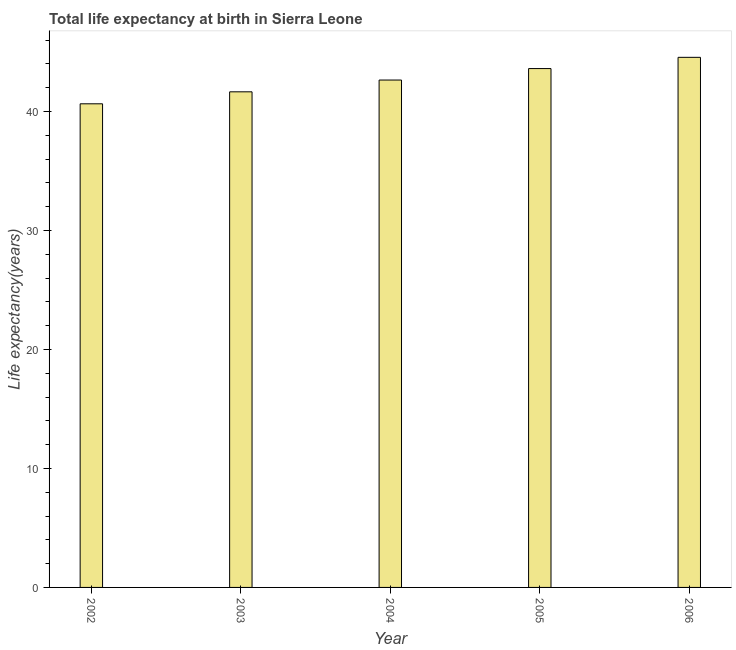Does the graph contain grids?
Ensure brevity in your answer.  No. What is the title of the graph?
Keep it short and to the point. Total life expectancy at birth in Sierra Leone. What is the label or title of the X-axis?
Make the answer very short. Year. What is the label or title of the Y-axis?
Keep it short and to the point. Life expectancy(years). What is the life expectancy at birth in 2006?
Your answer should be compact. 44.55. Across all years, what is the maximum life expectancy at birth?
Provide a succinct answer. 44.55. Across all years, what is the minimum life expectancy at birth?
Keep it short and to the point. 40.64. In which year was the life expectancy at birth minimum?
Your response must be concise. 2002. What is the sum of the life expectancy at birth?
Provide a short and direct response. 213.08. What is the difference between the life expectancy at birth in 2002 and 2005?
Your response must be concise. -2.96. What is the average life expectancy at birth per year?
Offer a very short reply. 42.62. What is the median life expectancy at birth?
Your response must be concise. 42.64. In how many years, is the life expectancy at birth greater than 24 years?
Your response must be concise. 5. What is the ratio of the life expectancy at birth in 2002 to that in 2004?
Offer a terse response. 0.95. What is the difference between the highest and the second highest life expectancy at birth?
Provide a succinct answer. 0.94. What is the difference between the highest and the lowest life expectancy at birth?
Offer a very short reply. 3.91. How many years are there in the graph?
Keep it short and to the point. 5. What is the Life expectancy(years) of 2002?
Make the answer very short. 40.64. What is the Life expectancy(years) in 2003?
Provide a short and direct response. 41.65. What is the Life expectancy(years) in 2004?
Offer a terse response. 42.64. What is the Life expectancy(years) of 2005?
Offer a very short reply. 43.6. What is the Life expectancy(years) of 2006?
Ensure brevity in your answer.  44.55. What is the difference between the Life expectancy(years) in 2002 and 2003?
Provide a short and direct response. -1.01. What is the difference between the Life expectancy(years) in 2002 and 2004?
Your answer should be compact. -2. What is the difference between the Life expectancy(years) in 2002 and 2005?
Your answer should be very brief. -2.96. What is the difference between the Life expectancy(years) in 2002 and 2006?
Offer a terse response. -3.91. What is the difference between the Life expectancy(years) in 2003 and 2004?
Keep it short and to the point. -0.99. What is the difference between the Life expectancy(years) in 2003 and 2005?
Provide a succinct answer. -1.95. What is the difference between the Life expectancy(years) in 2003 and 2006?
Your response must be concise. -2.9. What is the difference between the Life expectancy(years) in 2004 and 2005?
Make the answer very short. -0.96. What is the difference between the Life expectancy(years) in 2004 and 2006?
Offer a terse response. -1.91. What is the difference between the Life expectancy(years) in 2005 and 2006?
Your answer should be compact. -0.94. What is the ratio of the Life expectancy(years) in 2002 to that in 2003?
Give a very brief answer. 0.98. What is the ratio of the Life expectancy(years) in 2002 to that in 2004?
Ensure brevity in your answer.  0.95. What is the ratio of the Life expectancy(years) in 2002 to that in 2005?
Your answer should be very brief. 0.93. What is the ratio of the Life expectancy(years) in 2002 to that in 2006?
Your answer should be very brief. 0.91. What is the ratio of the Life expectancy(years) in 2003 to that in 2005?
Keep it short and to the point. 0.95. What is the ratio of the Life expectancy(years) in 2003 to that in 2006?
Offer a terse response. 0.94. What is the ratio of the Life expectancy(years) in 2004 to that in 2006?
Offer a very short reply. 0.96. What is the ratio of the Life expectancy(years) in 2005 to that in 2006?
Offer a terse response. 0.98. 